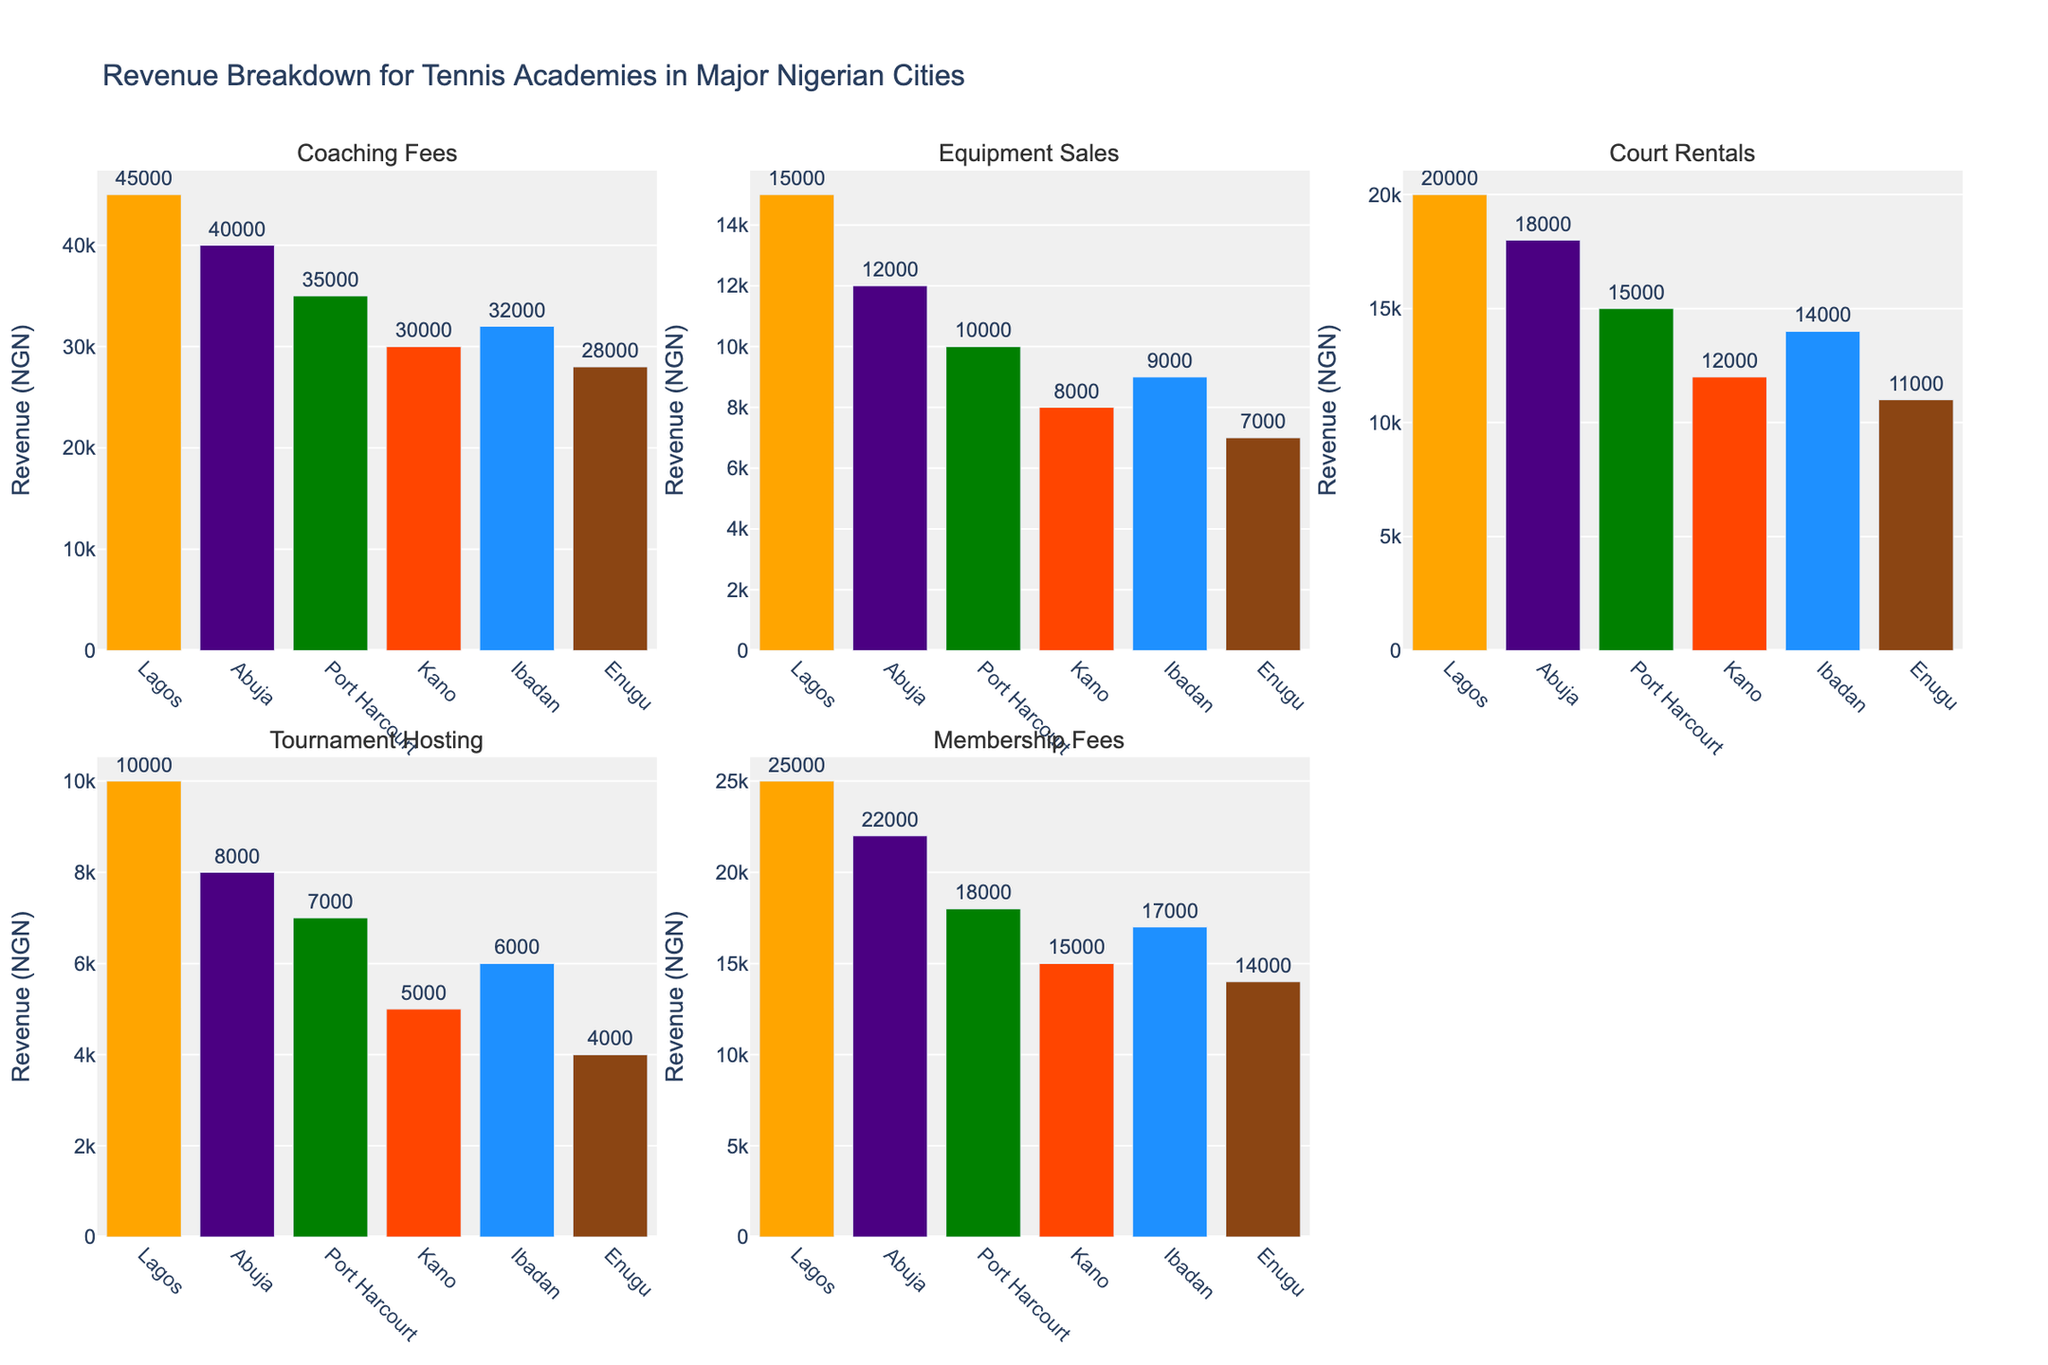What's the total revenue from Coaching Fees, Equipment Sales, and Court Rentals in Lagos? First, identify the revenue from each of these categories in Lagos. Coaching Fees = 45000, Equipment Sales = 15000, Court Rentals = 20000. Then, sum these values: 45000 + 15000 + 20000 = 80000.
Answer: 80000 Which city has the highest revenue from Membership Fees? Look at the Membership Fees subplot. Identify the city with the tallest bar. Lagos has the highest Membership Fees with 25000.
Answer: Lagos Compare the Coaching Fees between Abuja and Kano. Which city generates more revenue and by how much? Refer to the Coaching Fees subplot. Abuja's Coaching Fees = 40000 and Kano's Coaching Fees = 30000. Calculate the difference: 40000 - 30000 = 10000. Abuja generates more revenue by 10000.
Answer: Abuja, 10000 What is the total revenue from Tournament Hosting across all cities? Identify the Tournament Hosting revenue for each city: Lagos = 10000, Abuja = 8000, Port Harcourt = 7000, Kano = 5000, Ibadan = 6000, Enugu = 4000. Sum these values: 10000 + 8000 + 7000 + 5000 + 6000 + 4000 = 40000.
Answer: 40000 Which category has the largest variation in revenue among the cities? Examine each subplot and compare the difference between the highest and lowest revenues within each category. Coaching Fees have the largest variation, with Lagos at 45000 and Enugu at 28000, a difference of 17000.
Answer: Coaching Fees How does Equipment Sales revenue in Enugu compare to Port Harcourt? Look at the Equipment Sales subplot. Revenue in Enugu = 7000 and in Port Harcourt = 10000. Port Harcourt has higher revenue. Subtract Enugu's revenue from Port Harcourt's: 10000 - 7000 = 3000.
Answer: Port Harcourt, 3000 Which city has the lowest total revenue from Coaching Fees and Membership Fees combined? Calculate the combined total of Coaching Fees and Membership Fees for each city, then compare. Enugu: 28000 + 14000 = 42000, Kano: 30000 + 15000 = 45000, Ibadan: 32000 + 17000 = 49000, Port Harcourt: 35000 + 18000 = 53000, Abuja: 40000 + 22000 = 62000, Lagos: 45000 + 25000 = 70000. Enugu has the lowest combined revenue (42000).
Answer: Enugu What's the average revenue of Court Rentals across all cities? Identify Court Rentals revenue for each city, add them: 20000 (Lagos) + 18000 (Abuja) + 15000 (Port Harcourt) + 12000 (Kano) + 14000 (Ibadan) + 11000 (Enugu) = 90000. Divide this sum by the number of cities, which is 6: 90000 / 6 = 15000.
Answer: 15000 